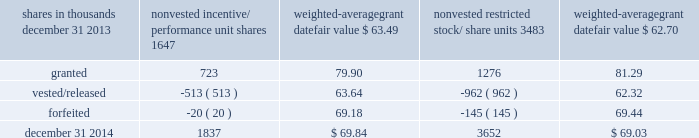To determine stock-based compensation expense , the grant date fair value is applied to the options granted with a reduction for estimated forfeitures .
We recognize compensation expense for stock options on a straight-line basis over the specified vesting period .
At december 31 , 2013 and 2012 , options for 10204000 and 12759000 shares of common stock were exercisable at a weighted-average price of $ 89.46 and $ 90.86 , respectively .
The total intrinsic value of options exercised during 2014 , 2013 and 2012 was $ 90 million , $ 86 million and $ 37 million , respectively .
Cash received from option exercises under all incentive plans for 2014 , 2013 and 2012 was approximately $ 215 million , $ 208 million and $ 118 million , respectively .
The tax benefit realized from option exercises under all incentive plans for 2014 , 2013 and 2012 was approximately $ 33 million , $ 31 million and $ 14 million , respectively .
Shares of common stock available during the next year for the granting of options and other awards under the incentive plans were 17997353 at december 31 , 2014 .
Total shares of pnc common stock authorized for future issuance under equity compensation plans totaled 19017057 shares at december 31 , 2014 , which includes shares available for issuance under the incentive plans and the employee stock purchase plan ( espp ) as described below .
During 2014 , we issued approximately 2.4 million shares from treasury stock in connection with stock option exercise activity .
As with past exercise activity , we currently intend to utilize primarily treasury stock for any future stock option exercises .
Awards granted to non-employee directors in 2014 , 2013 and 2012 include 21490 , 27076 and 25620 deferred stock units , respectively , awarded under the outside directors deferred stock unit plan .
A deferred stock unit is a phantom share of our common stock , which is accounted for as a liability until such awards are paid to the participants in cash .
As there are no vesting or service requirements on these awards , total compensation expense is recognized in full for these awards on the date of grant .
Incentive/performance unit share awards and restricted stock/share unit awards the fair value of nonvested incentive/performance unit share awards and restricted stock/share unit awards is initially determined based on prices not less than the market value of our common stock on the date of grant .
The value of certain incentive/performance unit share awards is subsequently remeasured based on the achievement of one or more financial and other performance goals .
The personnel and compensation committee ( 201cp&cc 201d ) of the board of directors approves the final award payout with respect to certain incentive/performance unit share awards .
These awards have either a three-year or a four-year performance period and are payable in either stock or a combination of stock and cash .
Restricted stock/share unit awards have various vesting periods generally ranging from 3 years to 5 years .
Beginning in 2013 , we incorporated several enhanced risk- related performance changes to certain long-term incentive compensation programs .
In addition to achieving certain financial performance metrics on both an absolute basis and relative to our peers , final payout amounts will be subject to reduction if pnc fails to meet certain risk-related performance metrics as specified in the award agreements .
However , the p&cc has the discretion to waive any or all of this reduction under certain circumstances .
The weighted-average grant date fair value of incentive/ performance unit share awards and restricted stock/unit awards granted in 2014 , 2013 and 2012 was $ 80.79 , $ 64.77 and $ 60.68 per share , respectively .
The total fair value of incentive/performance unit share and restricted stock/unit awards vested during 2014 , 2013 and 2012 was approximately $ 119 million , $ 63 million and $ 55 million , respectively .
We recognize compensation expense for such awards ratably over the corresponding vesting and/or performance periods for each type of program .
Table 121 : nonvested incentive/performance unit share awards and restricted stock/share unit awards 2013 rollforward shares in thousands nonvested incentive/ performance unit shares weighted- average grant date fair value nonvested restricted stock/ weighted- average grant date fair value .
The pnc financial services group , inc .
2013 form 10-k 185 .
In shares in thousands , for the non-vested incentive/ performance unit shares , what was the change in balance between december 31 2013 and december 31 2014? 
Computations: (1837 - 1647)
Answer: 190.0. To determine stock-based compensation expense , the grant date fair value is applied to the options granted with a reduction for estimated forfeitures .
We recognize compensation expense for stock options on a straight-line basis over the specified vesting period .
At december 31 , 2013 and 2012 , options for 10204000 and 12759000 shares of common stock were exercisable at a weighted-average price of $ 89.46 and $ 90.86 , respectively .
The total intrinsic value of options exercised during 2014 , 2013 and 2012 was $ 90 million , $ 86 million and $ 37 million , respectively .
Cash received from option exercises under all incentive plans for 2014 , 2013 and 2012 was approximately $ 215 million , $ 208 million and $ 118 million , respectively .
The tax benefit realized from option exercises under all incentive plans for 2014 , 2013 and 2012 was approximately $ 33 million , $ 31 million and $ 14 million , respectively .
Shares of common stock available during the next year for the granting of options and other awards under the incentive plans were 17997353 at december 31 , 2014 .
Total shares of pnc common stock authorized for future issuance under equity compensation plans totaled 19017057 shares at december 31 , 2014 , which includes shares available for issuance under the incentive plans and the employee stock purchase plan ( espp ) as described below .
During 2014 , we issued approximately 2.4 million shares from treasury stock in connection with stock option exercise activity .
As with past exercise activity , we currently intend to utilize primarily treasury stock for any future stock option exercises .
Awards granted to non-employee directors in 2014 , 2013 and 2012 include 21490 , 27076 and 25620 deferred stock units , respectively , awarded under the outside directors deferred stock unit plan .
A deferred stock unit is a phantom share of our common stock , which is accounted for as a liability until such awards are paid to the participants in cash .
As there are no vesting or service requirements on these awards , total compensation expense is recognized in full for these awards on the date of grant .
Incentive/performance unit share awards and restricted stock/share unit awards the fair value of nonvested incentive/performance unit share awards and restricted stock/share unit awards is initially determined based on prices not less than the market value of our common stock on the date of grant .
The value of certain incentive/performance unit share awards is subsequently remeasured based on the achievement of one or more financial and other performance goals .
The personnel and compensation committee ( 201cp&cc 201d ) of the board of directors approves the final award payout with respect to certain incentive/performance unit share awards .
These awards have either a three-year or a four-year performance period and are payable in either stock or a combination of stock and cash .
Restricted stock/share unit awards have various vesting periods generally ranging from 3 years to 5 years .
Beginning in 2013 , we incorporated several enhanced risk- related performance changes to certain long-term incentive compensation programs .
In addition to achieving certain financial performance metrics on both an absolute basis and relative to our peers , final payout amounts will be subject to reduction if pnc fails to meet certain risk-related performance metrics as specified in the award agreements .
However , the p&cc has the discretion to waive any or all of this reduction under certain circumstances .
The weighted-average grant date fair value of incentive/ performance unit share awards and restricted stock/unit awards granted in 2014 , 2013 and 2012 was $ 80.79 , $ 64.77 and $ 60.68 per share , respectively .
The total fair value of incentive/performance unit share and restricted stock/unit awards vested during 2014 , 2013 and 2012 was approximately $ 119 million , $ 63 million and $ 55 million , respectively .
We recognize compensation expense for such awards ratably over the corresponding vesting and/or performance periods for each type of program .
Table 121 : nonvested incentive/performance unit share awards and restricted stock/share unit awards 2013 rollforward shares in thousands nonvested incentive/ performance unit shares weighted- average grant date fair value nonvested restricted stock/ weighted- average grant date fair value .
The pnc financial services group , inc .
2013 form 10-k 185 .
What was the total fair value of incentive/performance unit share and restricted stock/unit awards vested during 2014 and 2013 in millions? 
Computations: (119 + 63)
Answer: 182.0. 